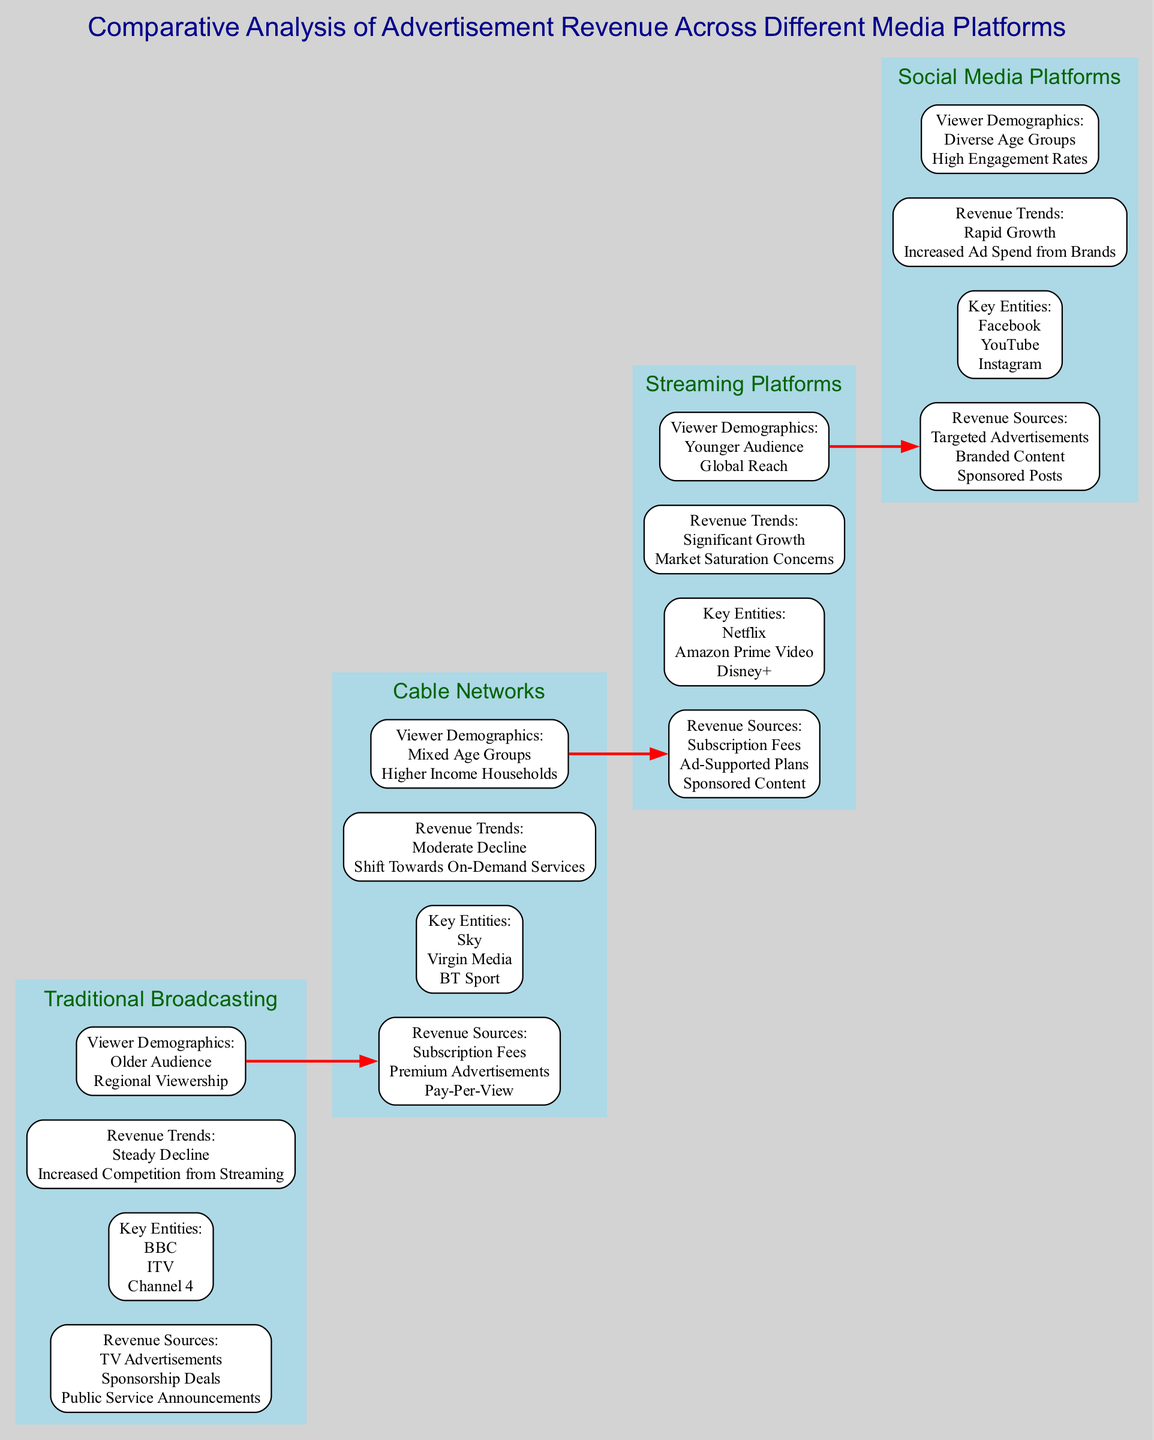What are the revenue sources for Traditional Broadcasting? The diagram lists the revenue sources for Traditional Broadcasting which include TV Advertisements, Sponsorship Deals, and Public Service Announcements.
Answer: TV Advertisements, Sponsorship Deals, Public Service Announcements Which key entity is associated with Cable Networks? By examining the Cable Networks stage in the diagram, the key entities are identified as Sky, Virgin Media, and BT Sport. Any one of these would be a reasonable answer.
Answer: Sky What is the revenue trend for Streaming Platforms? The Streaming Platforms section indicates the revenue trend as Significant Growth and Market Saturation Concerns. Both elements are required to answer fully, yet the first part is the primary aspect.
Answer: Significant Growth How many elements are listed under Social Media Platforms? The diagram details three elements under Social Media Platforms: Revenue Sources, Key Entities, and Revenue Trends. The total count of distinct elements therefore yields the answer.
Answer: 3 Which viewer demographic is primarily associated with Traditional Broadcasting? The diagram specifies Older Audience and Regional Viewership as the viewer demographics for Traditional Broadcasting. The focus here is on the first element mentioned.
Answer: Older Audience What kind of advertising revenue growth is seen in Social Media Platforms? By reviewing the Social Media Platforms section, the revenue trend outlines Rapid Growth and Increased Ad Spend from Brands. The first part is highlighted here for the query.
Answer: Rapid Growth What is the relationship flow from Cable Networks to Streaming Platforms? The diagram shows a bold red edge from the last element of Cable Networks to the first element of Streaming Platforms, illustrating a clear directional flow showing their connection.
Answer: Bold red edge How does the viewer demographic of Streaming Platforms contrast with that of Traditional Broadcasting? Streaming Platforms target a Younger Audience and Global Reach, while Traditional Broadcasting has an Older Audience and Regional Viewership, showcasing the generational and geographical difference in demographics.
Answer: Younger Audience vs. Older Audience What is the primary difference in revenue sources between Cable Networks and Streaming Platforms? Examining the two stages, Cable Networks predominantly earn from Subscription Fees, Premium Advertisements, and Pay-Per-View, whereas Streaming Platforms derive income from Subscription Fees, Ad-Supported Plans, and Sponsored Content. The more distinguishing aspect would be the Ad-Supported Plans unique to Streaming.
Answer: Ad-Supported Plans 